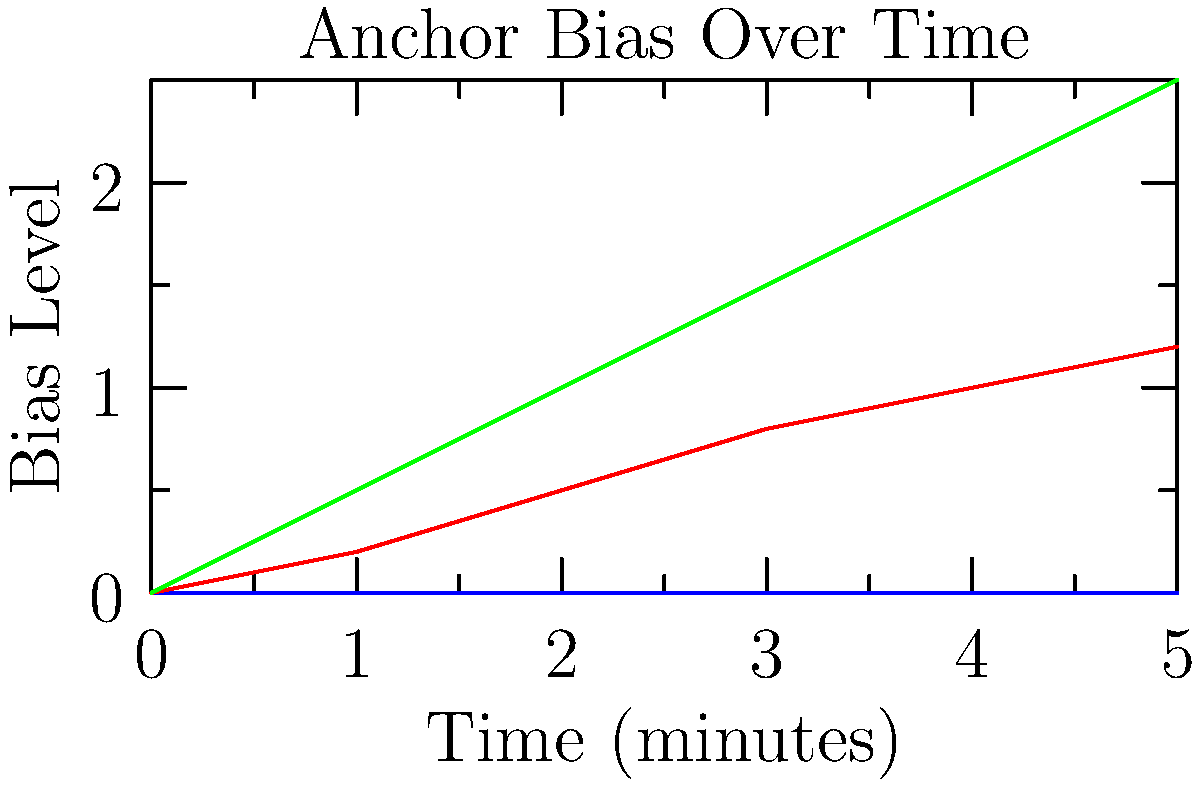Based on the graph showing different patterns of news anchor bias over time, which line would be most challenging for an AI model to accurately detect and classify? To answer this question, we need to analyze the three lines in the graph:

1. Blue line (Neutral): This line remains constant at 0 bias level throughout the time period. It represents a news anchor maintaining a completely neutral tone.

2. Green line (Obvious): This line shows a clear and steady increase in bias level over time. It represents an anchor becoming progressively more biased in their reporting.

3. Red line (Subtle): This line shows a gradual and slight increase in bias level over time. It represents an anchor subtly shifting their tone and expression.

When considering AI model detection:

1. The Neutral line would be relatively easy to detect due to its constant value.
2. The Obvious line would also be easier to detect due to its clear and significant changes.
3. The Subtle line presents the most challenge because:
   a) The changes are gradual and less pronounced.
   b) The overall change is smaller compared to the Obvious line.
   c) It requires more sensitive detection of minor variations in tone and expression.

For a skeptical viewer analyzing for biased narratives, the subtle changes represented by the red line would be the most critical to identify, as they are less noticeable but can still significantly influence the audience's perception.

Therefore, the red line (Subtle) would be the most challenging for an AI model to accurately detect and classify.
Answer: Subtle (red line) 